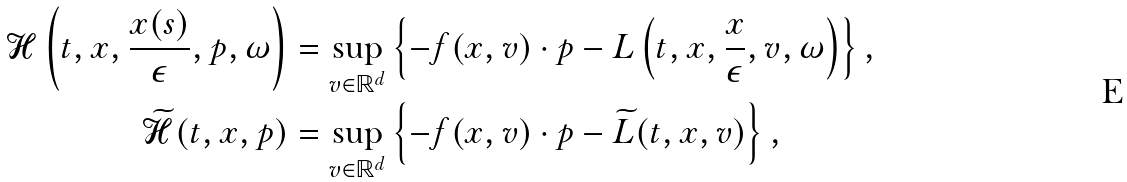Convert formula to latex. <formula><loc_0><loc_0><loc_500><loc_500>\mathcal { H } \left ( t , x , \frac { x ( s ) } { \epsilon } , p , \omega \right ) & = \sup _ { v \in \mathbb { R } ^ { d } } \left \{ - f ( x , v ) \cdot p - L \left ( t , x , \frac { x } { \epsilon } , v , \omega \right ) \right \} , \\ \widetilde { \mathcal { H } } ( t , x , p ) & = \sup _ { v \in \mathbb { R } ^ { d } } \left \{ - f ( x , v ) \cdot p - \widetilde { L } ( t , x , v ) \right \} ,</formula> 